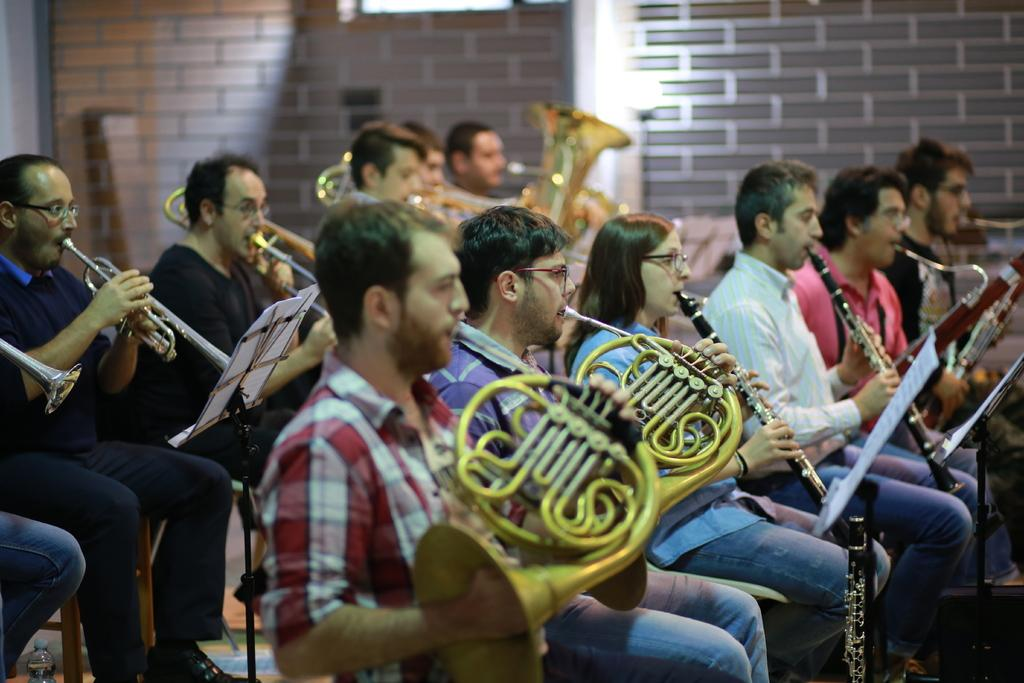What are the persons in the image doing? The persons in the image are playing musical instruments. What objects are present in the image that might be used to support the musical instruments? There are stands in the image that might be used to support the musical instruments. What items can be seen on the stands? There are papers on the stands. What is the location of the bottle in the image? The bottle is in the image. What can be seen in the background of the image? There is a wall in the background of the image. What type of wool is being spun by the persons in the image? There is no wool or spinning activity present in the image; the persons are playing musical instruments. How many potatoes can be seen on the stands in the image? There are no potatoes present in the image; there are papers on the stands. 